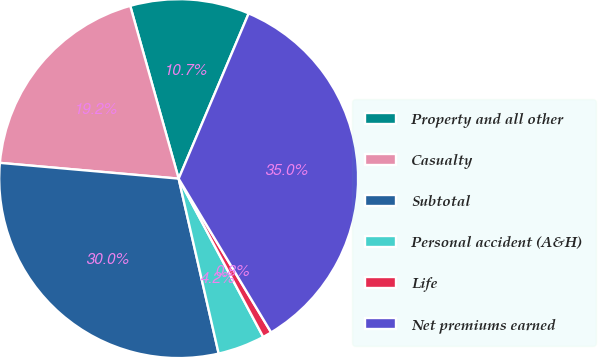<chart> <loc_0><loc_0><loc_500><loc_500><pie_chart><fcel>Property and all other<fcel>Casualty<fcel>Subtotal<fcel>Personal accident (A&H)<fcel>Life<fcel>Net premiums earned<nl><fcel>10.73%<fcel>19.25%<fcel>29.98%<fcel>4.23%<fcel>0.81%<fcel>35.0%<nl></chart> 